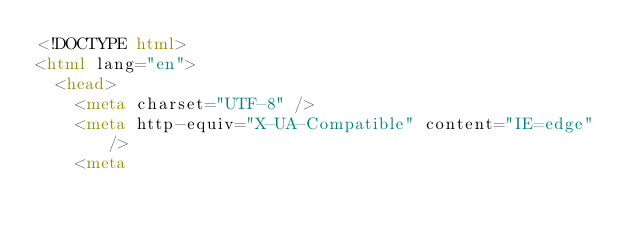<code> <loc_0><loc_0><loc_500><loc_500><_HTML_><!DOCTYPE html>
<html lang="en">
  <head>
    <meta charset="UTF-8" />
    <meta http-equiv="X-UA-Compatible" content="IE=edge" />
    <meta</code> 